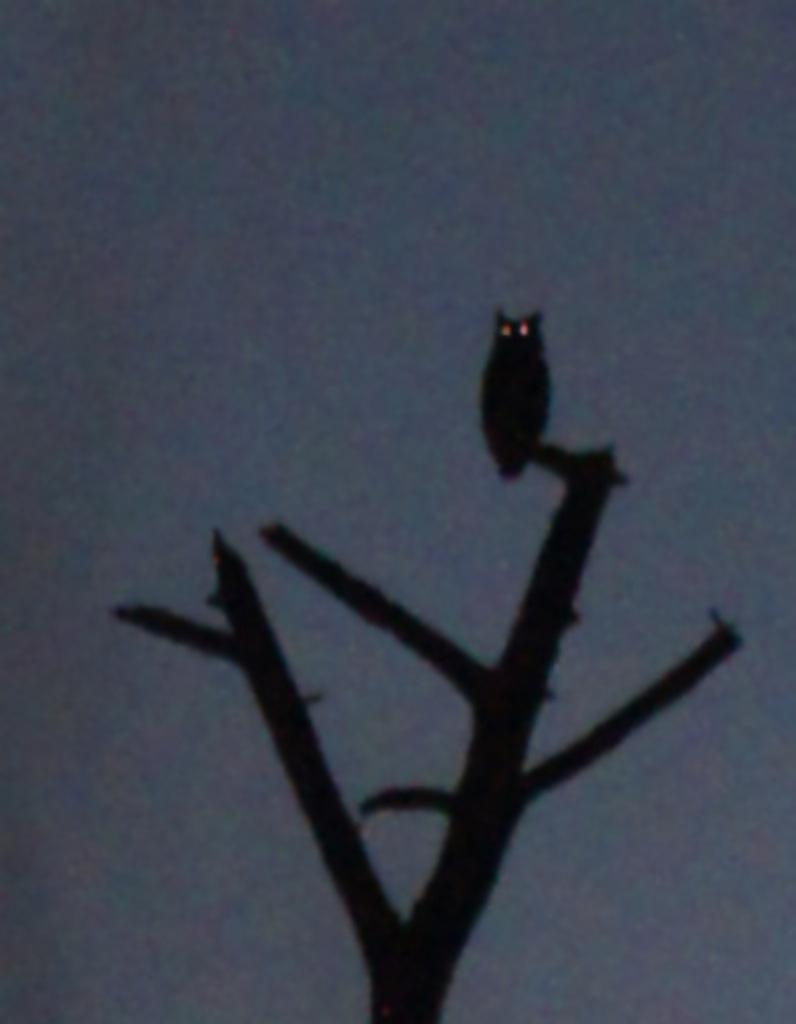What animal can be seen in the image? There is an owl in the image. Where is the owl located? The owl is on a tree branch. What can be seen in the background of the image? There is sky visible in the background of the image. What type of honey is the owl collecting from the desk in the image? There is no desk or honey present in the image; it features an owl on a tree branch with sky visible in the background. 